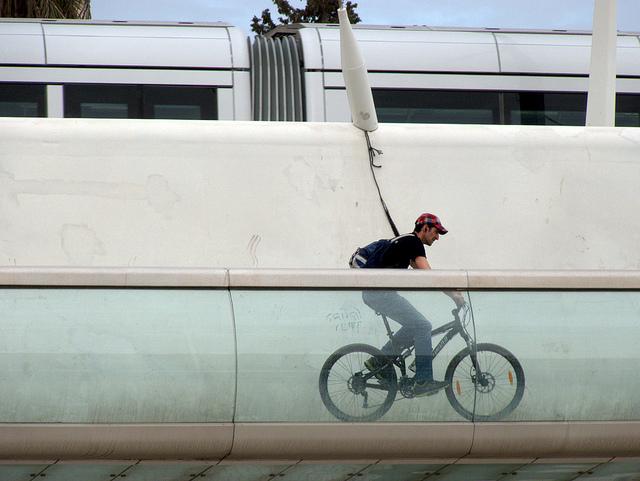What is the man wearing?
Write a very short answer. Backpack. What is this person riding?
Quick response, please. Bike. What mode of transportation is in the background?
Answer briefly. Train. 